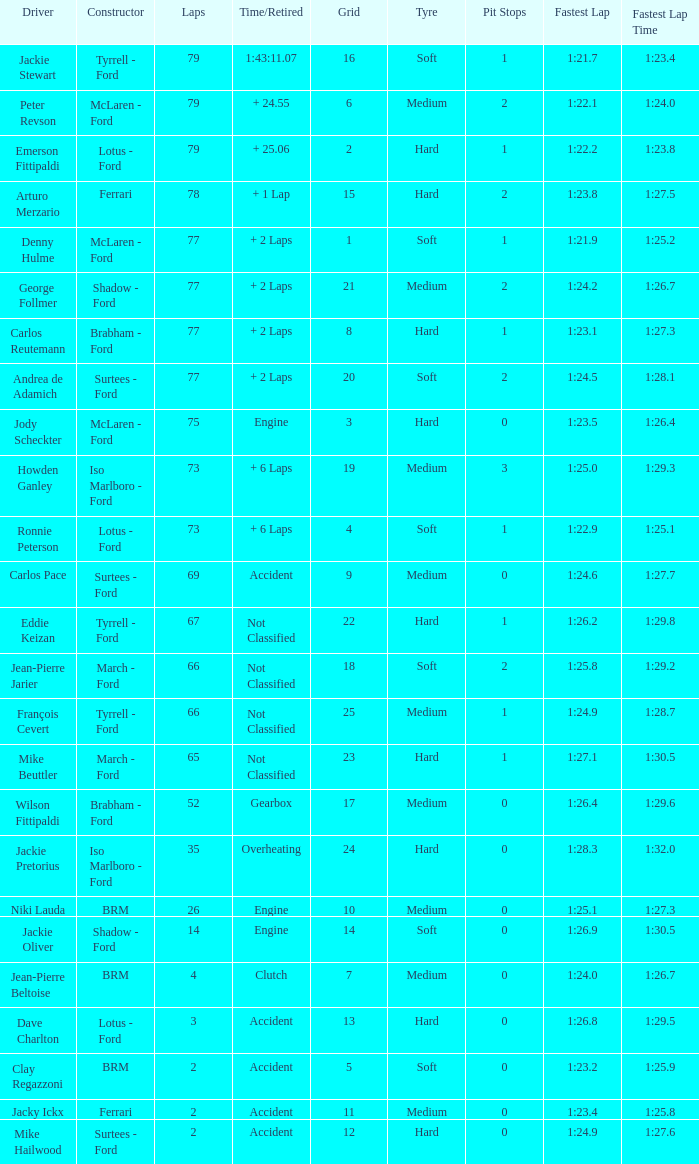How much time is required for less than 35 laps and less than 10 grids? Clutch, Accident. 